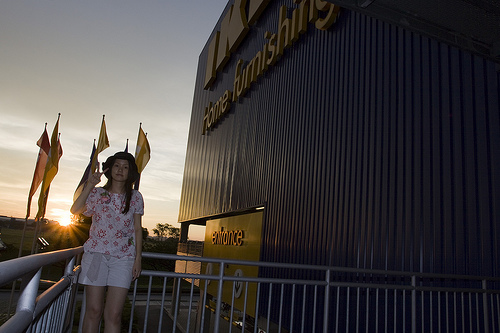<image>
Can you confirm if the woman is behind the building? No. The woman is not behind the building. From this viewpoint, the woman appears to be positioned elsewhere in the scene. Is the building next to the girl? Yes. The building is positioned adjacent to the girl, located nearby in the same general area. 